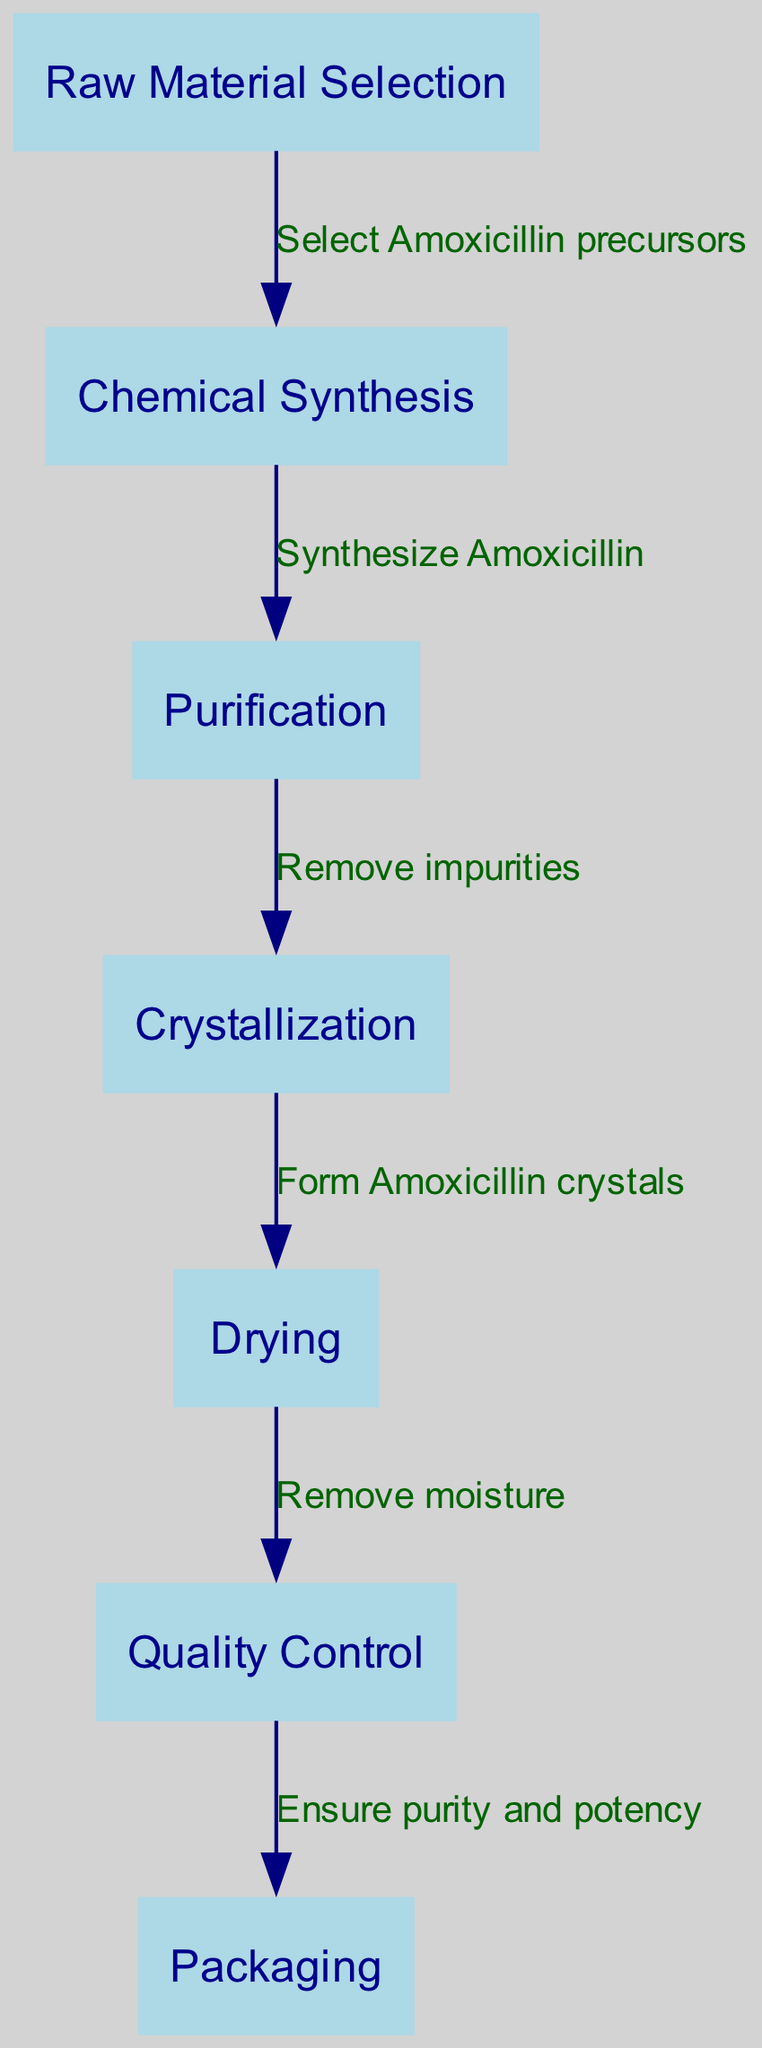What is the first step in the synthesis process? The first step in the flowchart is labeled as "Raw Material Selection," indicating that the process begins with selecting the necessary raw materials for drug synthesis.
Answer: Raw Material Selection How many nodes are present in the diagram? By counting the entries in the "nodes" section of the data, there are a total of 7 nodes listed, representing different stages in the drug synthesis process.
Answer: 7 What is the last step before Packaging? Looking at the flow from the "Quality Control" node directly to the "Packaging" node, we see that "Quality Control" is the last step before the final packaging stage of the antibiotic.
Answer: Quality Control What label connects Chemical Synthesis to Purification? The edge that connects the "Chemical Synthesis" node to the "Purification" node is labeled "Synthesize Amoxicillin," which describes the action taken at this step in the process.
Answer: Synthesize Amoxicillin Which step involves removing impurities? The flowchart indicates that the "Purification" step is specifically concerned with removing impurities from the synthesized product, as described by the related edge label.
Answer: Purification What is the connection between Crystallization and Drying? The connection indicates that after crystallization is completed, the next step involves removing moisture, as depicted by the edge labeled "Remove moisture" that connects these two nodes.
Answer: Remove moisture What is the final step in the synthesis process? The last node in the flowchart is labeled "Packaging," indicating that packaging is the final step in the entire synthesis process of the antibiotic.
Answer: Packaging Which step comes directly after Drying? The flowchart shows that after the "Drying" step, the next step is "Quality Control," indicating that this process ensures the quality of the product following drying.
Answer: Quality Control 